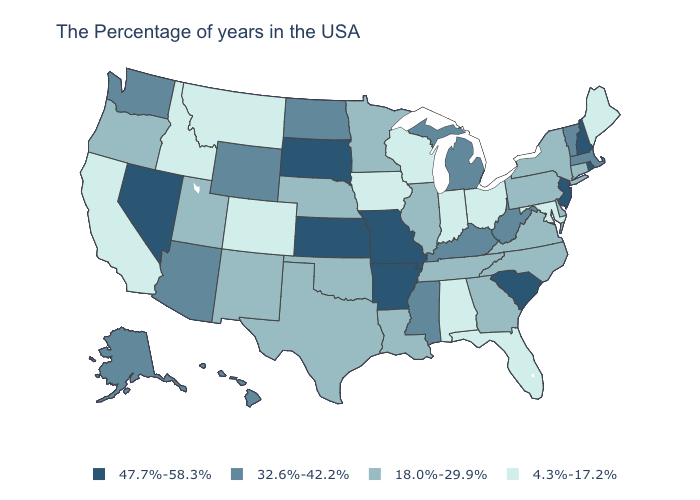Does the map have missing data?
Give a very brief answer. No. Name the states that have a value in the range 18.0%-29.9%?
Answer briefly. Connecticut, New York, Delaware, Pennsylvania, Virginia, North Carolina, Georgia, Tennessee, Illinois, Louisiana, Minnesota, Nebraska, Oklahoma, Texas, New Mexico, Utah, Oregon. Does the map have missing data?
Write a very short answer. No. Which states have the highest value in the USA?
Write a very short answer. Rhode Island, New Hampshire, New Jersey, South Carolina, Missouri, Arkansas, Kansas, South Dakota, Nevada. Among the states that border Minnesota , which have the highest value?
Give a very brief answer. South Dakota. Name the states that have a value in the range 18.0%-29.9%?
Keep it brief. Connecticut, New York, Delaware, Pennsylvania, Virginia, North Carolina, Georgia, Tennessee, Illinois, Louisiana, Minnesota, Nebraska, Oklahoma, Texas, New Mexico, Utah, Oregon. What is the value of New York?
Short answer required. 18.0%-29.9%. What is the value of North Carolina?
Short answer required. 18.0%-29.9%. Does Delaware have the same value as Michigan?
Concise answer only. No. What is the lowest value in the USA?
Short answer required. 4.3%-17.2%. Does Maine have the lowest value in the Northeast?
Concise answer only. Yes. Does Missouri have the highest value in the MidWest?
Write a very short answer. Yes. Among the states that border Tennessee , which have the highest value?
Keep it brief. Missouri, Arkansas. Does Michigan have a higher value than Texas?
Short answer required. Yes. Does the first symbol in the legend represent the smallest category?
Quick response, please. No. 